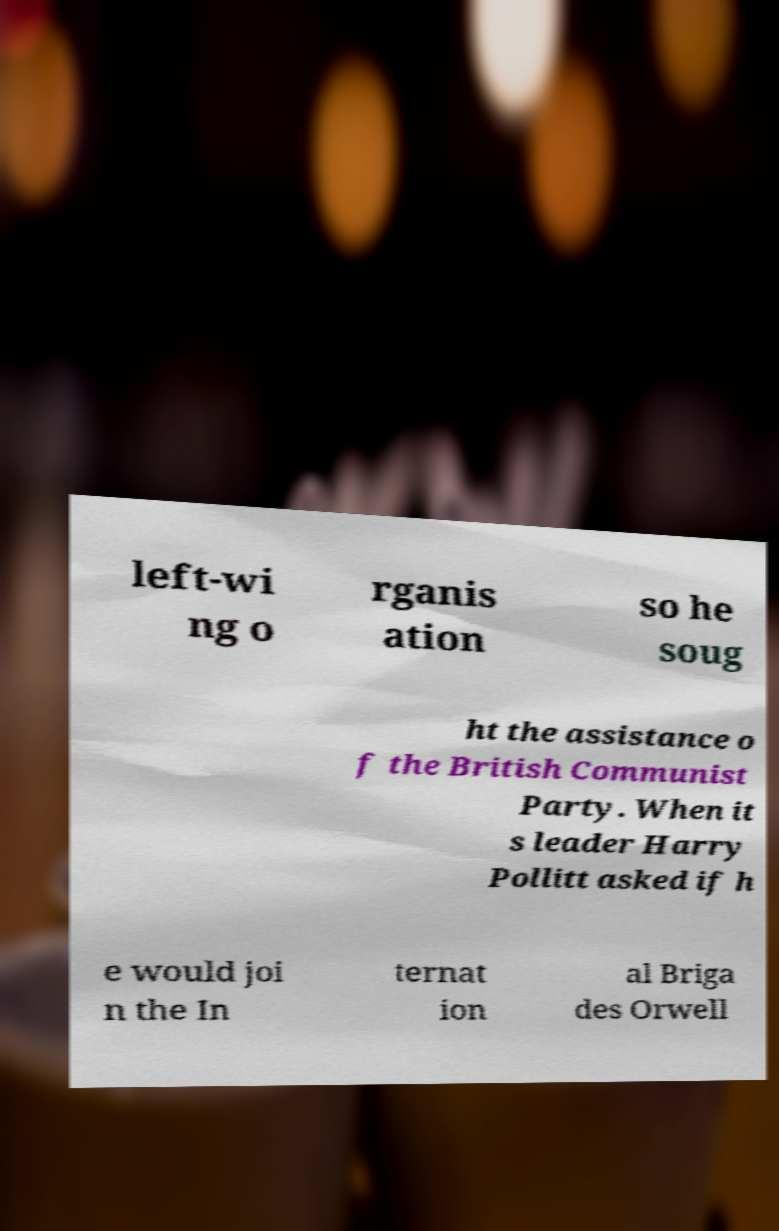For documentation purposes, I need the text within this image transcribed. Could you provide that? left-wi ng o rganis ation so he soug ht the assistance o f the British Communist Party. When it s leader Harry Pollitt asked if h e would joi n the In ternat ion al Briga des Orwell 